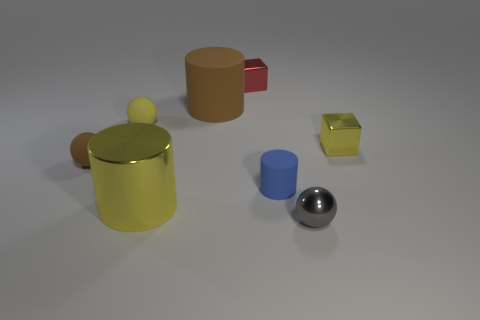How many cylinders are either yellow things or small brown things?
Make the answer very short. 1. Are there more small red things right of the tiny brown object than tiny rubber balls that are behind the red shiny cube?
Ensure brevity in your answer.  Yes. There is a sphere that is behind the small yellow shiny cube; how many small blue things are behind it?
Offer a terse response. 0. How many objects are blue rubber objects or small yellow balls?
Your answer should be compact. 2. Does the big rubber thing have the same shape as the small red thing?
Keep it short and to the point. No. What material is the small blue cylinder?
Offer a terse response. Rubber. How many objects are on the right side of the large brown thing and in front of the tiny yellow matte ball?
Provide a succinct answer. 3. Does the brown cylinder have the same size as the yellow metal cube?
Offer a terse response. No. There is a brown matte object that is right of the brown ball; is it the same size as the gray metal sphere?
Provide a succinct answer. No. There is a matte cylinder that is on the right side of the small red metallic cube; what is its color?
Provide a succinct answer. Blue. 